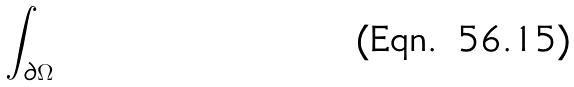Convert formula to latex. <formula><loc_0><loc_0><loc_500><loc_500>\int _ { \partial \Omega }</formula> 